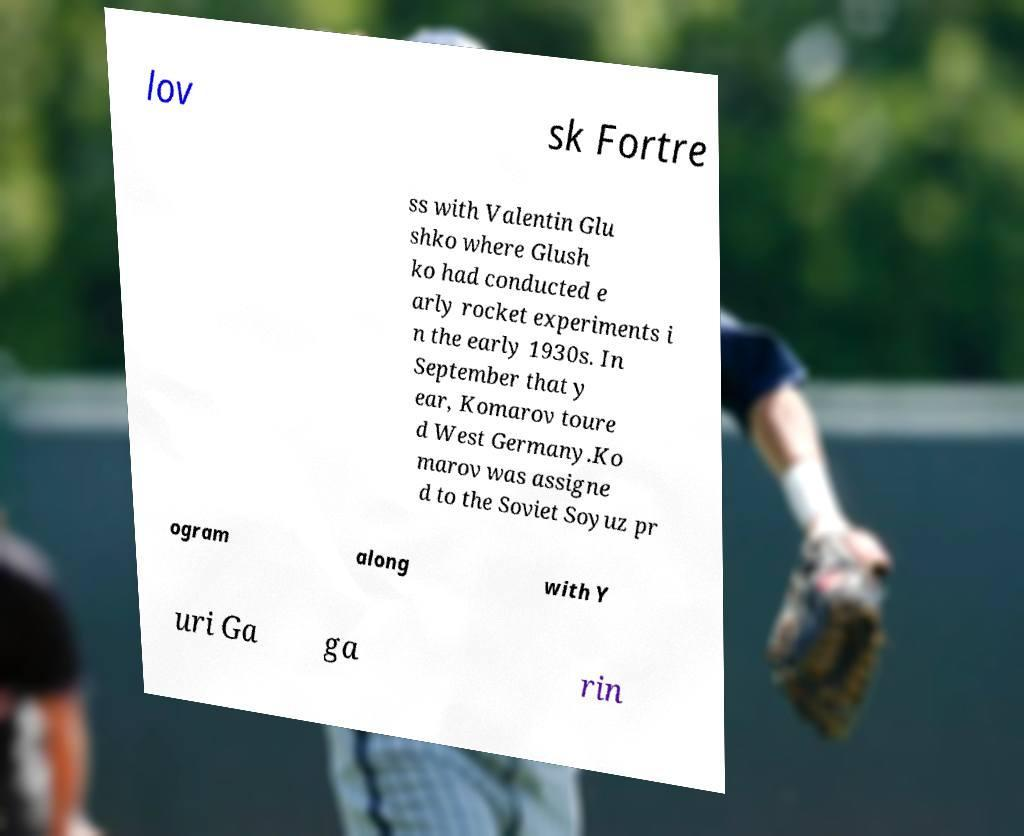I need the written content from this picture converted into text. Can you do that? lov sk Fortre ss with Valentin Glu shko where Glush ko had conducted e arly rocket experiments i n the early 1930s. In September that y ear, Komarov toure d West Germany.Ko marov was assigne d to the Soviet Soyuz pr ogram along with Y uri Ga ga rin 